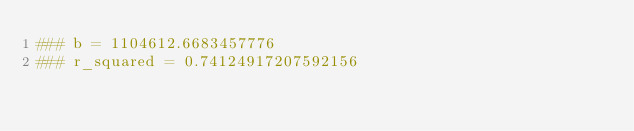<code> <loc_0><loc_0><loc_500><loc_500><_Bash_>### b = 1104612.6683457776
### r_squared = 0.74124917207592156
</code> 